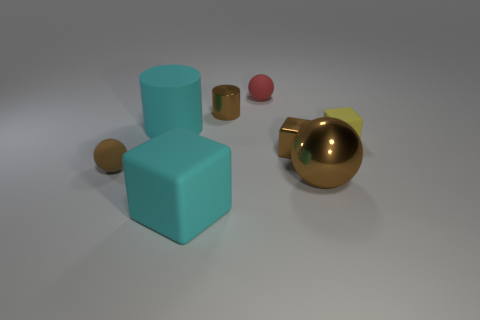The tiny rubber thing that is the same color as the big sphere is what shape?
Give a very brief answer. Sphere. There is a matte sphere that is to the left of the big matte thing that is in front of the brown rubber object; how many small matte spheres are behind it?
Offer a very short reply. 1. What is the size of the ball that is in front of the matte thing to the left of the big cylinder?
Keep it short and to the point. Large. There is a cylinder that is the same material as the brown block; what is its size?
Your answer should be very brief. Small. The small thing that is both in front of the tiny yellow thing and on the left side of the small brown metal block has what shape?
Keep it short and to the point. Sphere. Are there an equal number of brown rubber spheres behind the matte cylinder and cyan rubber blocks?
Make the answer very short. No. What number of objects are either small yellow matte things or shiny things that are behind the large brown object?
Offer a very short reply. 3. Is there a small brown metallic object of the same shape as the small yellow object?
Provide a succinct answer. Yes. Are there an equal number of tiny rubber balls in front of the big sphere and matte spheres that are right of the tiny brown cylinder?
Give a very brief answer. No. How many cyan objects are either big rubber blocks or metal cylinders?
Provide a succinct answer. 1. 